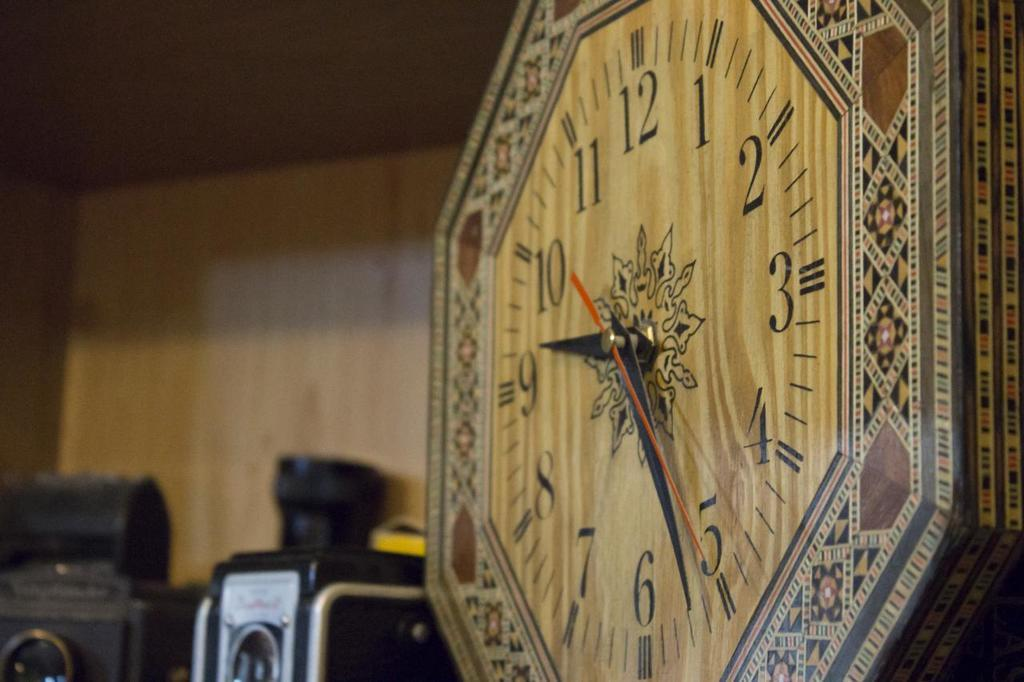<image>
Render a clear and concise summary of the photo. Old brown clock which has the hands on the numbers 9 and 5. 